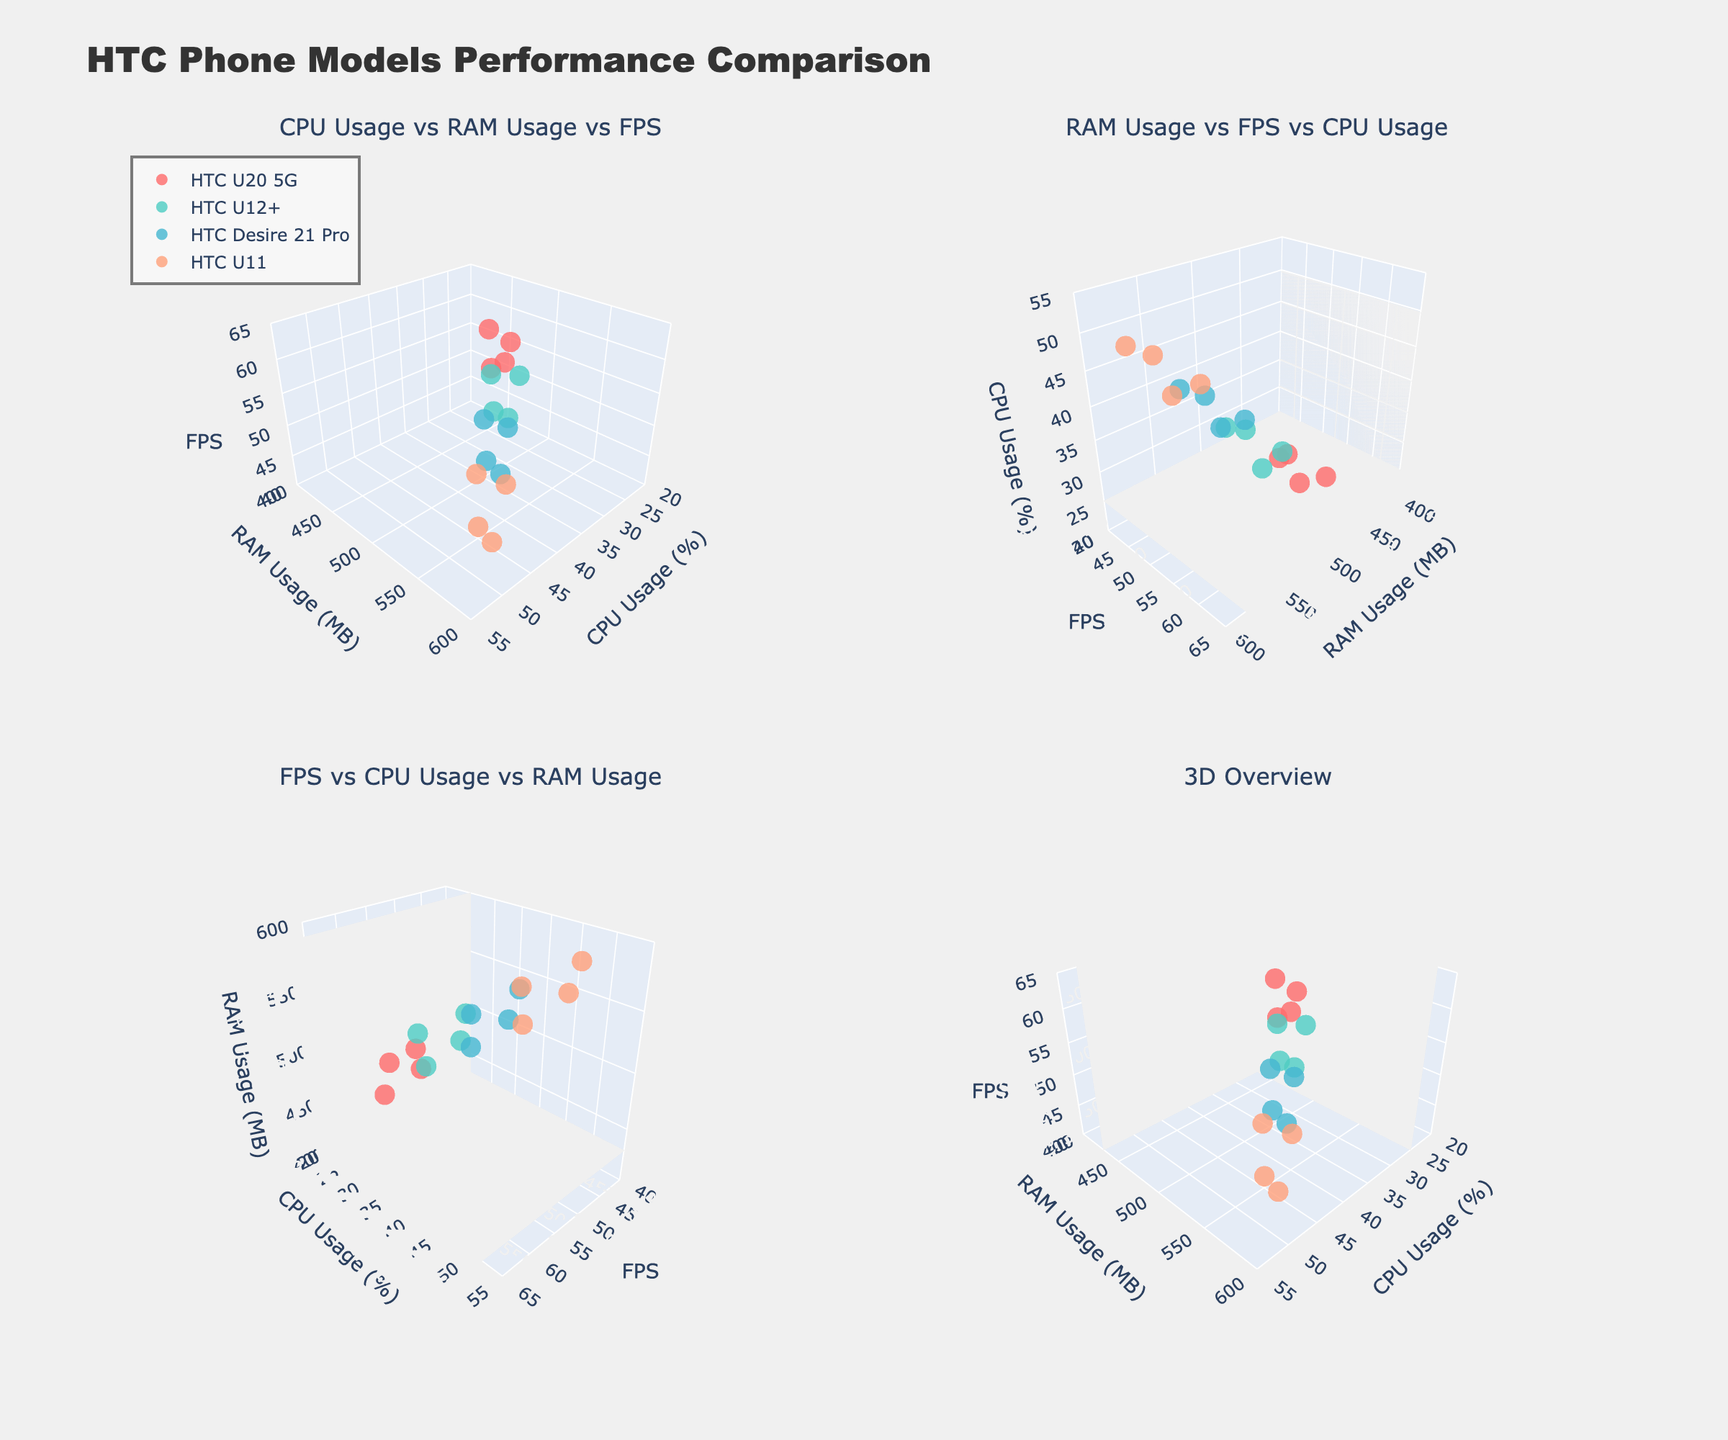How many different HTC models are compared in the 3D scatter plots? In the figure, we see that different sets of markers represent different HTC models. There are four unique sets of colors, each corresponding to one model. Hence, we count four models.
Answer: Four Which app shows the highest FPS on the HTC U11 model across the plots? By looking at the scatter plots and identifying the markers corresponding to the HTC U11 (which appear in a specific color), we can see that TikTok has the highest FPS for the HTC U11, reaching a value of 47.
Answer: TikTok Is there a difference in CPU usage for Facebook between the HTC U20 5G and HTC U11 models? By locating the markers for Facebook on the HTC U20 5G and HTC U11 in the CPU usage axis (x-axis), we can compare their positions. HTC U20 5G uses 25% CPU for Facebook, while HTC U11 uses 40%. The difference is 40% - 25% = 15%.
Answer: 15% Which HTC model has the lowest RAM usage for YouTube, and what is the value? We locate the markers for YouTube across all models by referring to the RAM usage axis. For each subplot, identify the least RAM usage, which for YouTube is on the HTC U20 5G with 490 MB.
Answer: HTC U20 5G, 490 MB On which subplot can we best observe the relationship between FPS and RAM usage? The subplot labeled "RAM Usage vs FPS vs CPU Usage" most directly compares RAM usage on the x-axis with FPS on the y-axis, making it most suitable for observing their relationship.
Answer: RAM Usage vs FPS vs CPU Usage Which app consumes the most CPU on the HTC U12+ as shown in the plots? By checking the scatter points corresponding to the HTC U12+ and observing the CPU usage axis, the highest CPU-consuming app on the HTC U12+ is TikTok with 40%.
Answer: TikTok Compare the FPS of Instagram on the HTC Desire 21 Pro and HTC U12+. Which is better? By finding the markers for Instagram on both HTC Desire 21 Pro and HTC U12+ and comparing their FPS on the z-axis, we see that HTC Desire 21 Pro has an FPS of 48, while HTC U12+ has an FPS of 52. HTC U12+ has the better FPS.
Answer: HTC U12+ What is the overall trend of RAM usage versus FPS across all models in the first subplot? The first subplot shows RAM usage vs FPS vs CPU usage. By observing the distribution of points, we see a pattern where higher RAM usage tends to associate with slightly lower FPS but is not a strict correlation. For instance, when RAM usage increases from 450 to 590 MB, FPS tends to stay within 45 to 60.
Answer: Higher RAM usage tends to slightly reduce FPS, with no strict correlation Which model has the most consistent FPS across the four apps based on the plots? By comparing the scatter points' z-coordinates (FPS) for each model, HTC U20 5G shows FPS values of 58, 55, 60, and 59, which are quite close. The variance is low compared to other models, indicating consistency.
Answer: HTC U20 5G 